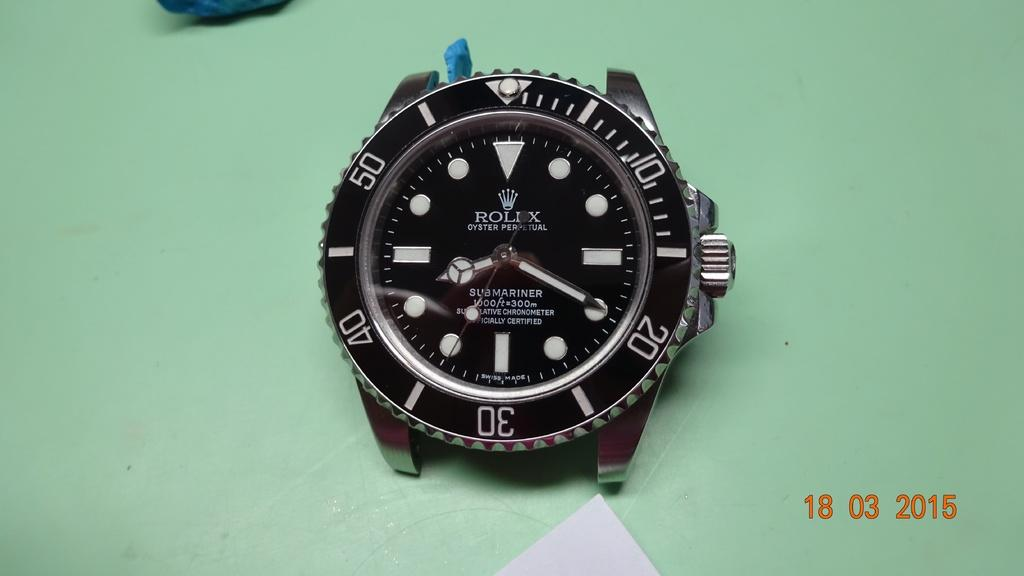<image>
Write a terse but informative summary of the picture. A Rolex watch has the word submariner on the face. 